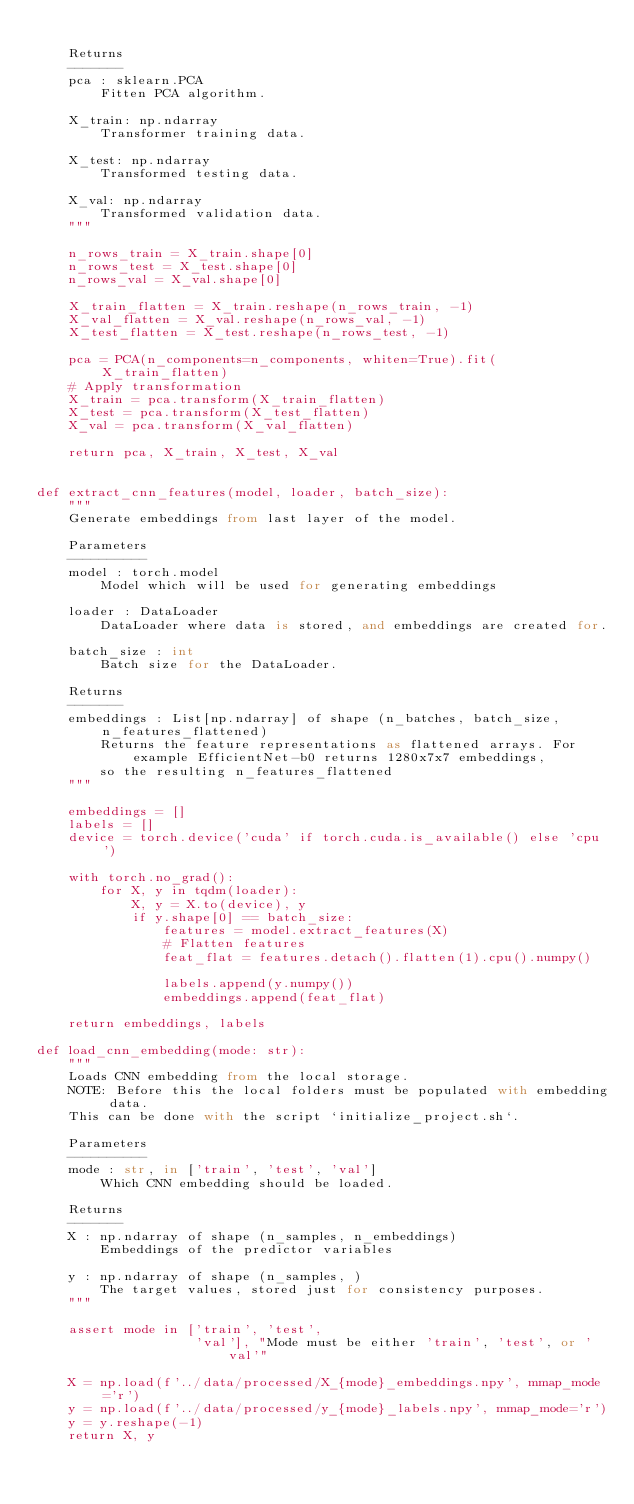Convert code to text. <code><loc_0><loc_0><loc_500><loc_500><_Python_>
    Returns
    -------
    pca : sklearn.PCA
        Fitten PCA algorithm.

    X_train: np.ndarray
        Transformer training data.

    X_test: np.ndarray
        Transformed testing data.

    X_val: np.ndarray
        Transformed validation data.
    """

    n_rows_train = X_train.shape[0]
    n_rows_test = X_test.shape[0]
    n_rows_val = X_val.shape[0]

    X_train_flatten = X_train.reshape(n_rows_train, -1)
    X_val_flatten = X_val.reshape(n_rows_val, -1)
    X_test_flatten = X_test.reshape(n_rows_test, -1)

    pca = PCA(n_components=n_components, whiten=True).fit(X_train_flatten)
    # Apply transformation
    X_train = pca.transform(X_train_flatten)
    X_test = pca.transform(X_test_flatten)
    X_val = pca.transform(X_val_flatten)

    return pca, X_train, X_test, X_val


def extract_cnn_features(model, loader, batch_size):
    """
    Generate embeddings from last layer of the model.

    Parameters
    ----------
    model : torch.model
        Model which will be used for generating embeddings

    loader : DataLoader
        DataLoader where data is stored, and embeddings are created for.

    batch_size : int
        Batch size for the DataLoader.

    Returns
    ------- 
    embeddings : List[np.ndarray] of shape (n_batches, batch_size, n_features_flattened)
        Returns the feature representations as flattened arrays. For example EfficientNet-b0 returns 1280x7x7 embeddings,
        so the resulting n_features_flattened
    """

    embeddings = []
    labels = []
    device = torch.device('cuda' if torch.cuda.is_available() else 'cpu')

    with torch.no_grad():
        for X, y in tqdm(loader):
            X, y = X.to(device), y
            if y.shape[0] == batch_size:
                features = model.extract_features(X)
                # Flatten features
                feat_flat = features.detach().flatten(1).cpu().numpy()

                labels.append(y.numpy())
                embeddings.append(feat_flat)

    return embeddings, labels

def load_cnn_embedding(mode: str):
    """
    Loads CNN embedding from the local storage.
    NOTE: Before this the local folders must be populated with embedding data.
    This can be done with the script `initialize_project.sh`.
    
    Parameters
    ----------
    mode : str, in ['train', 'test', 'val']
        Which CNN embedding should be loaded.

    Returns
    -------
    X : np.ndarray of shape (n_samples, n_embeddings) 
        Embeddings of the predictor variables

    y : np.ndarray of shape (n_samples, )
        The target values, stored just for consistency purposes.
    """

    assert mode in ['train', 'test',
                    'val'], "Mode must be either 'train', 'test', or 'val'"

    X = np.load(f'../data/processed/X_{mode}_embeddings.npy', mmap_mode='r')
    y = np.load(f'../data/processed/y_{mode}_labels.npy', mmap_mode='r')
    y = y.reshape(-1)
    return X, y
</code> 